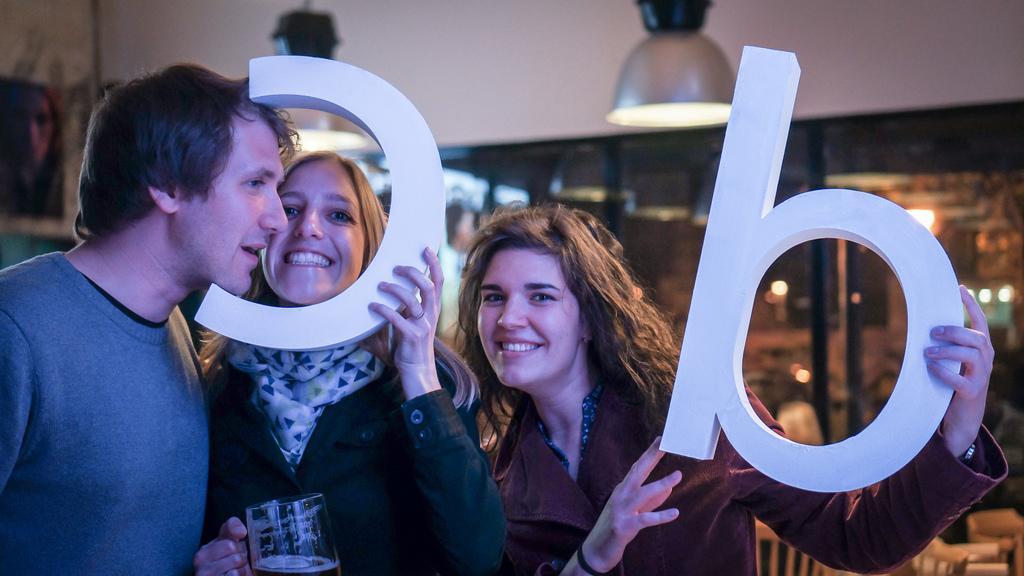Could you give a brief overview of what you see in this image? In the center of the image we can see three persons are standing and they are smiling and they are in different costumes. Among them, we can see two persons are holding some objects. In the background there is a wall, glass, one poster, chairs, lights, hanging lamps and a few other objects. 